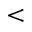<formula> <loc_0><loc_0><loc_500><loc_500><</formula> 